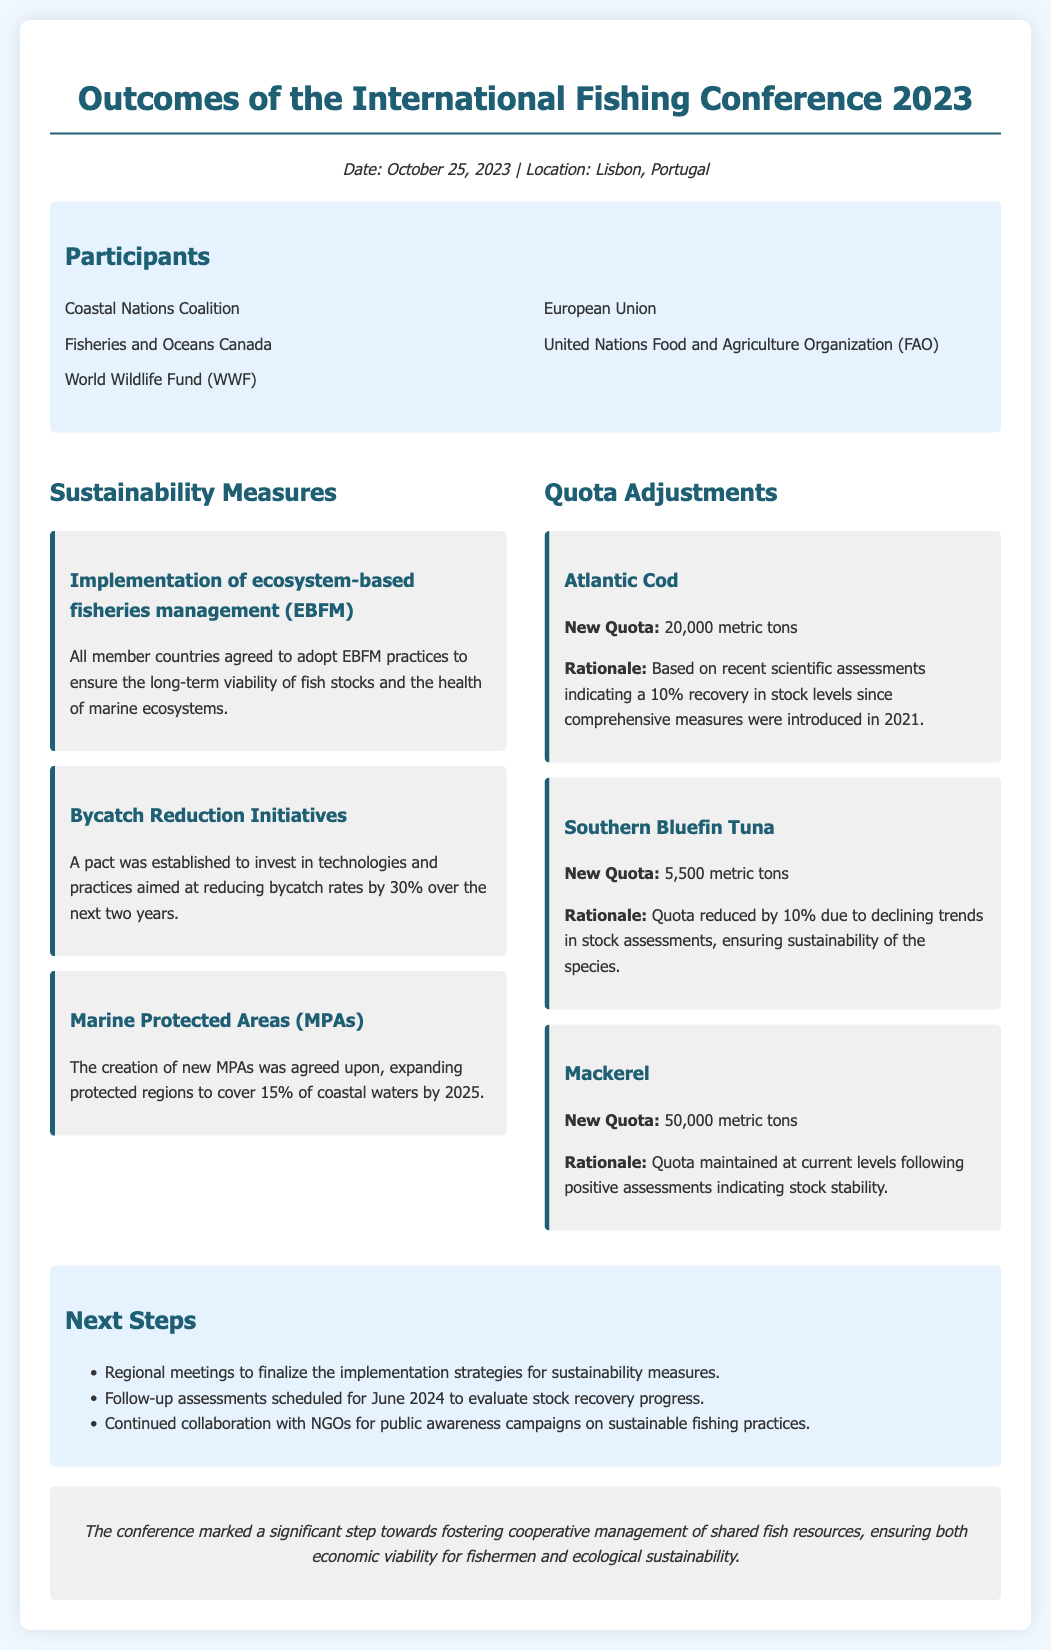What is the date of the conference? The date is provided in the meta-info section of the document as October 25, 2023.
Answer: October 25, 2023 Where was the conference held? The location is mentioned in the meta-info section of the document as Lisbon, Portugal.
Answer: Lisbon, Portugal What sustainability measure involves reducing bycatch rates? The document specifies "Bycatch Reduction Initiatives" as the measure aimed at reducing bycatch rates.
Answer: Bycatch Reduction Initiatives What is the new quota for Atlantic Cod? The new quota is mentioned under the quota adjustments section, specifically for Atlantic Cod as 20,000 metric tons.
Answer: 20,000 metric tons What percentage of coastal waters do the new Marine Protected Areas aim to cover by 2025? The document states that new Marine Protected Areas aim to cover 15% of coastal waters by 2025.
Answer: 15% What was the rationale for the quota adjustment of Southern Bluefin Tuna? The rationale given is due to declining trends in stock assessments, ensuring sustainability of the species.
Answer: Declining trends in stock assessments How much is the quota for Mackerel maintained at? The document indicates that the quota for Mackerel is maintained at 50,000 metric tons.
Answer: 50,000 metric tons What follow-up assessments are scheduled for June 2024? The document mentions follow-up assessments scheduled to evaluate stock recovery progress.
Answer: Evaluate stock recovery progress What key stakeholder participated in the conference apart from coastal nations? The document lists the "European Union" as a participant apart from coastal nations.
Answer: European Union 